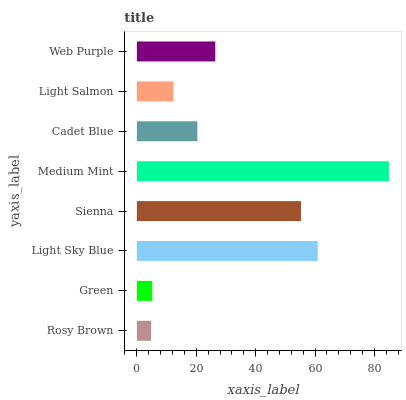Is Rosy Brown the minimum?
Answer yes or no. Yes. Is Medium Mint the maximum?
Answer yes or no. Yes. Is Green the minimum?
Answer yes or no. No. Is Green the maximum?
Answer yes or no. No. Is Green greater than Rosy Brown?
Answer yes or no. Yes. Is Rosy Brown less than Green?
Answer yes or no. Yes. Is Rosy Brown greater than Green?
Answer yes or no. No. Is Green less than Rosy Brown?
Answer yes or no. No. Is Web Purple the high median?
Answer yes or no. Yes. Is Cadet Blue the low median?
Answer yes or no. Yes. Is Light Sky Blue the high median?
Answer yes or no. No. Is Green the low median?
Answer yes or no. No. 